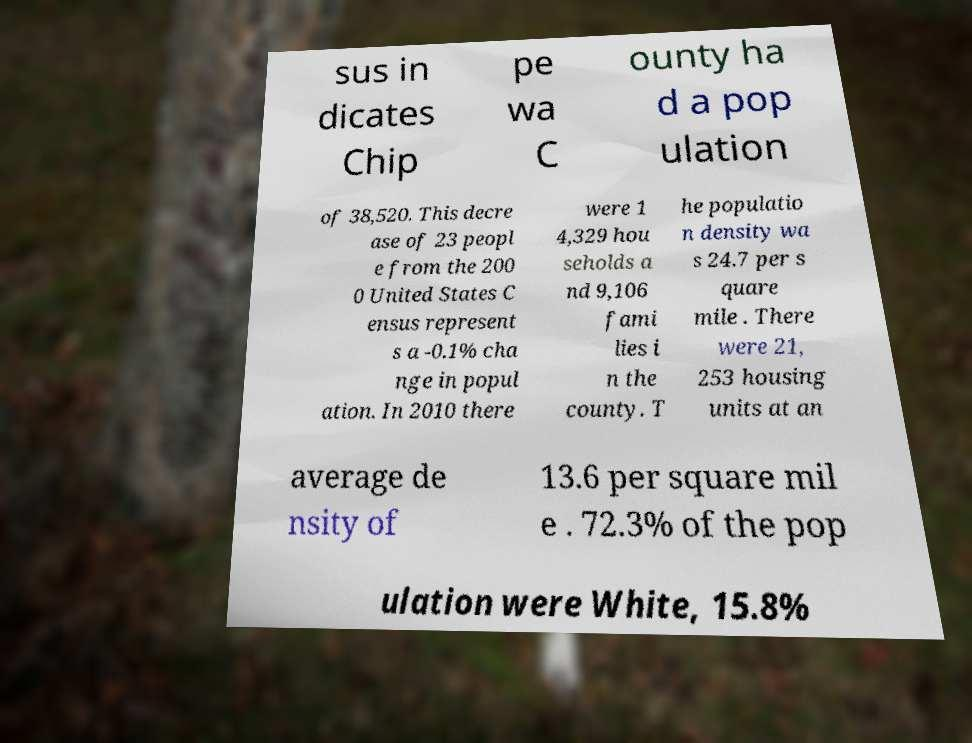For documentation purposes, I need the text within this image transcribed. Could you provide that? sus in dicates Chip pe wa C ounty ha d a pop ulation of 38,520. This decre ase of 23 peopl e from the 200 0 United States C ensus represent s a -0.1% cha nge in popul ation. In 2010 there were 1 4,329 hou seholds a nd 9,106 fami lies i n the county. T he populatio n density wa s 24.7 per s quare mile . There were 21, 253 housing units at an average de nsity of 13.6 per square mil e . 72.3% of the pop ulation were White, 15.8% 